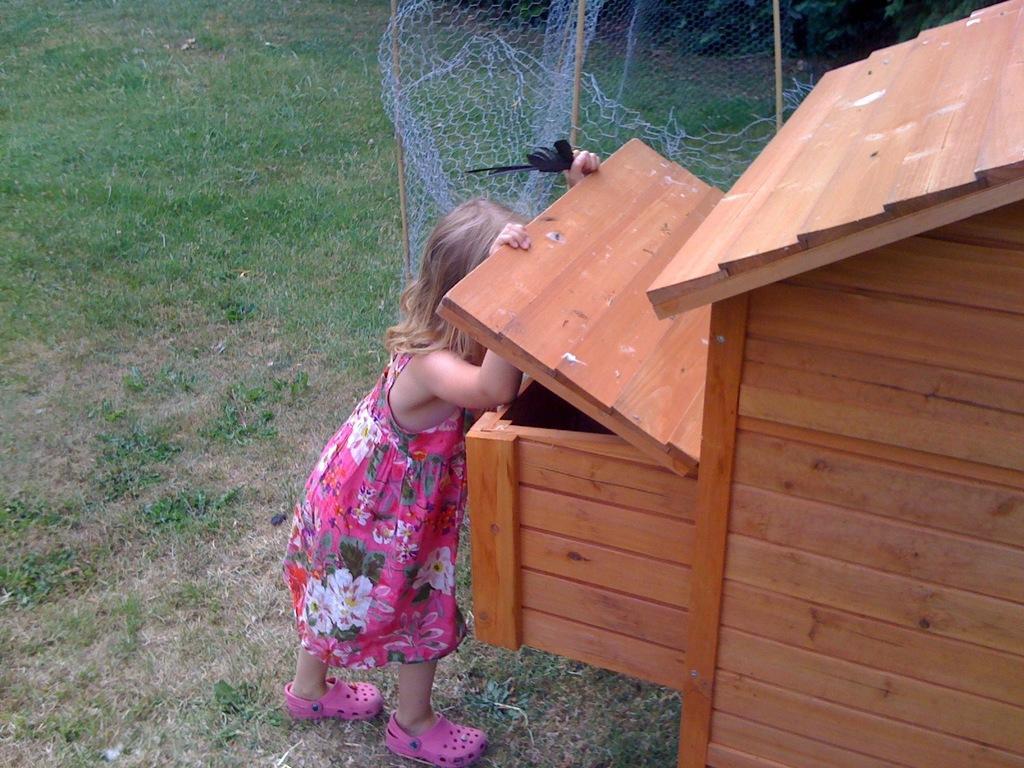Can you describe this image briefly? In this image there is one kid standing and holding a wooden object as we can see in the middle of this image. There is a net wall on the top of this image. There is a grassy land in the background. 